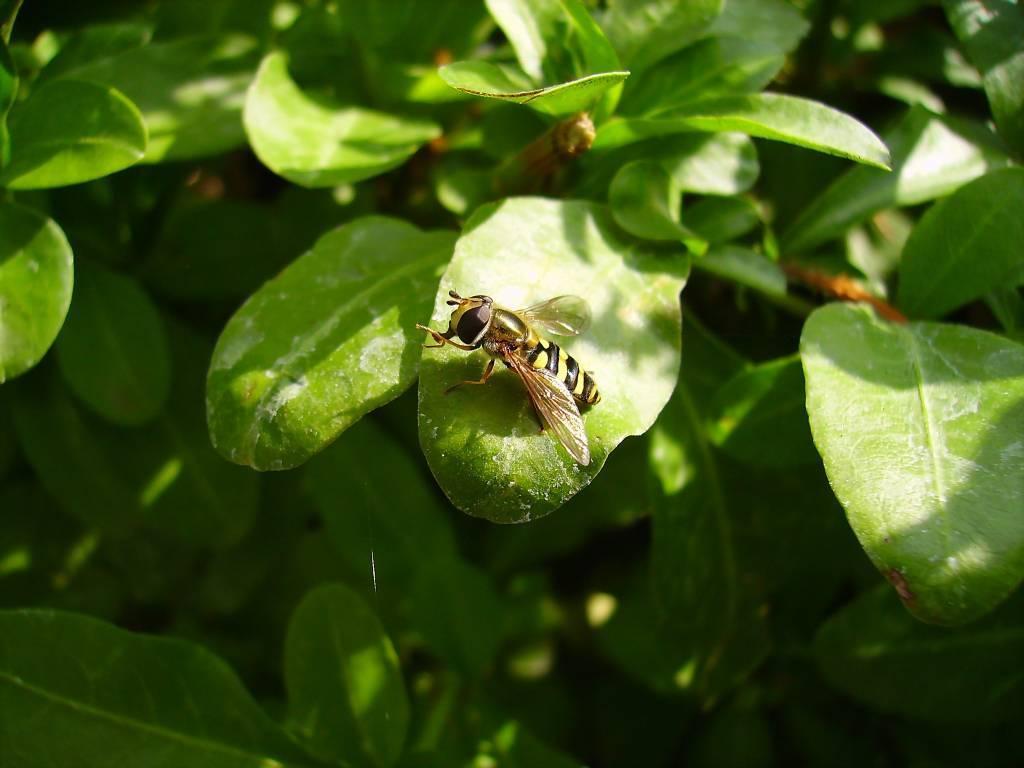In one or two sentences, can you explain what this image depicts? In this image there are leaves of a plant. In the center there is a honey bee on a leaf. 